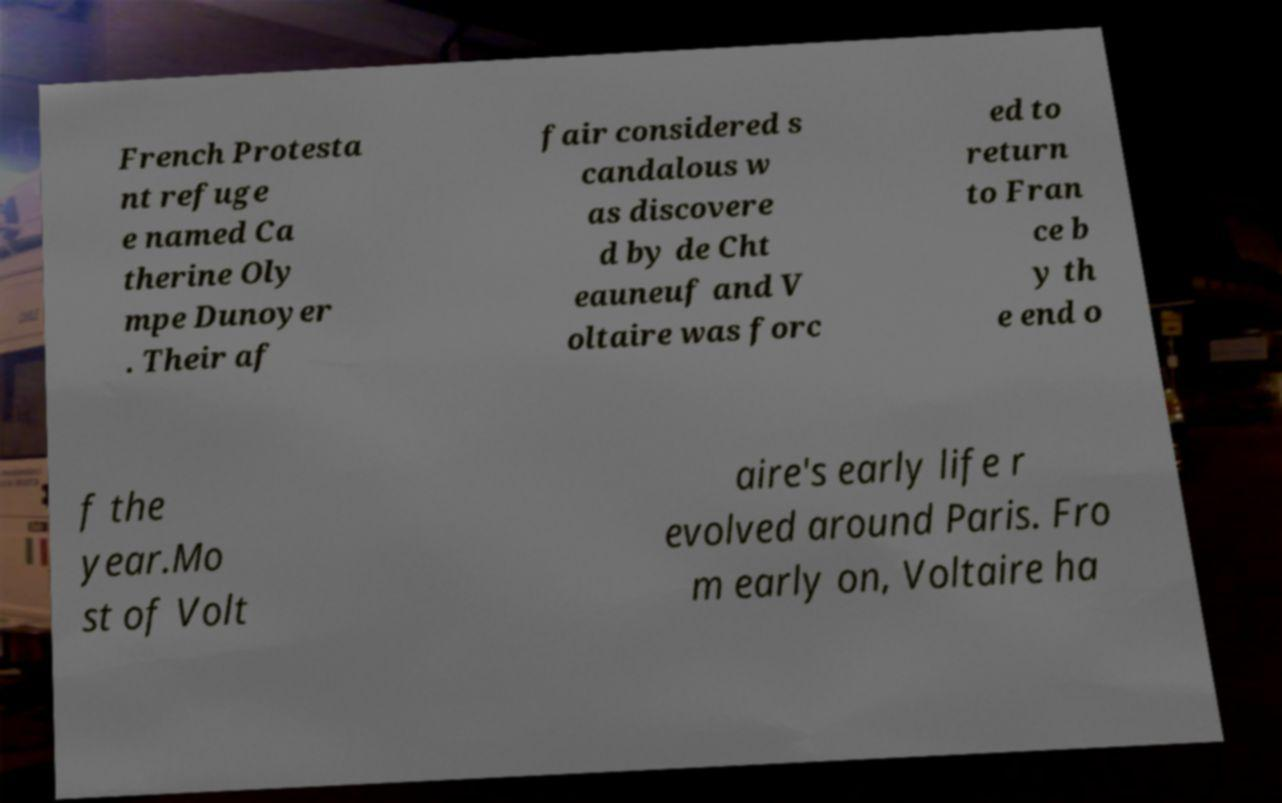Could you assist in decoding the text presented in this image and type it out clearly? French Protesta nt refuge e named Ca therine Oly mpe Dunoyer . Their af fair considered s candalous w as discovere d by de Cht eauneuf and V oltaire was forc ed to return to Fran ce b y th e end o f the year.Mo st of Volt aire's early life r evolved around Paris. Fro m early on, Voltaire ha 